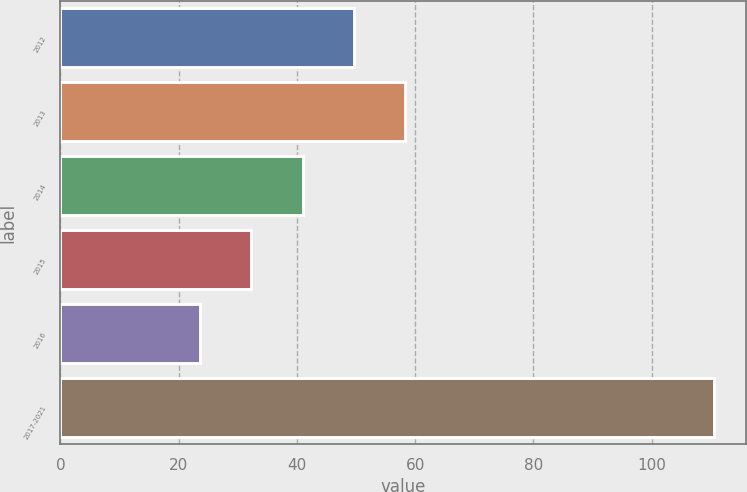<chart> <loc_0><loc_0><loc_500><loc_500><bar_chart><fcel>2012<fcel>2013<fcel>2014<fcel>2015<fcel>2016<fcel>2017-2021<nl><fcel>49.67<fcel>58.36<fcel>40.98<fcel>32.29<fcel>23.6<fcel>110.5<nl></chart> 